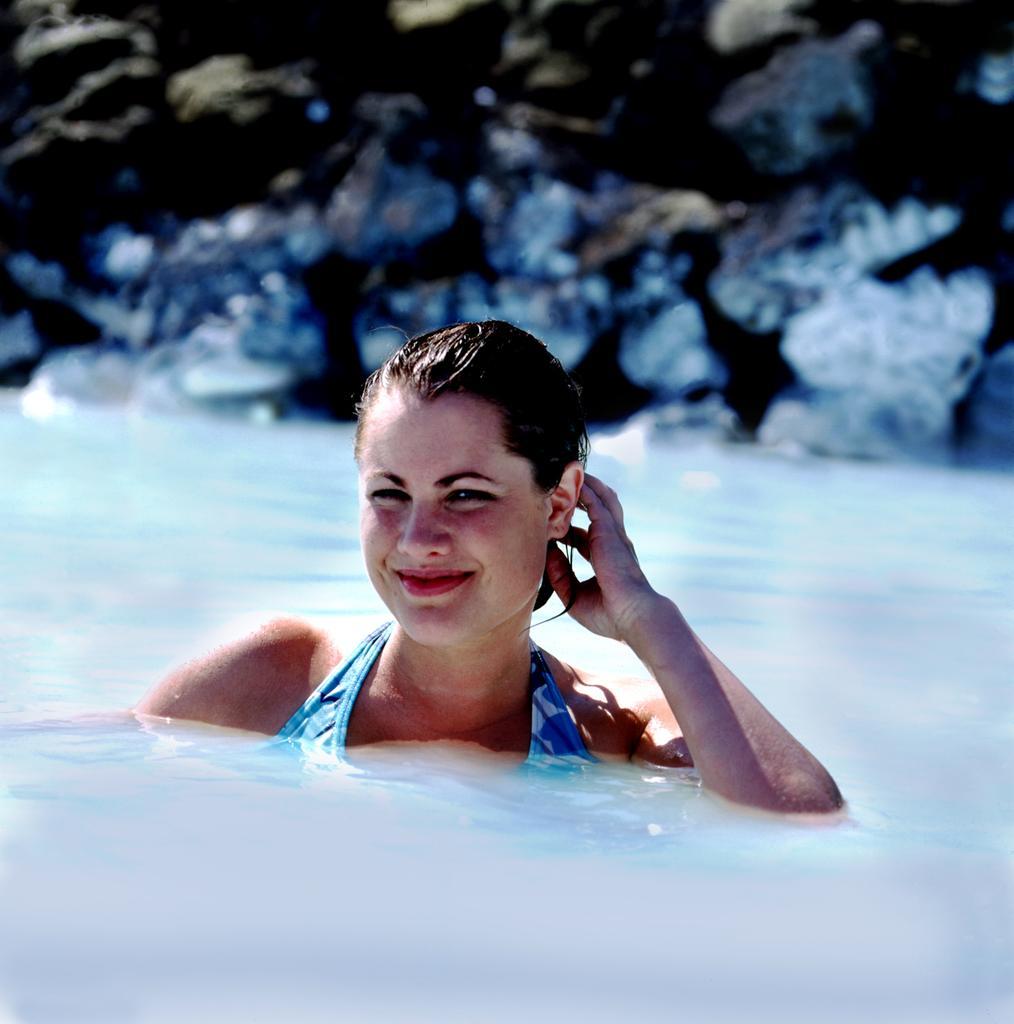Please provide a concise description of this image. This image is taken outdoors. In the background there are a few rocks. In the middle of the image a woman is swimming in the pool. At the bottom of the image there is a pool with water. 